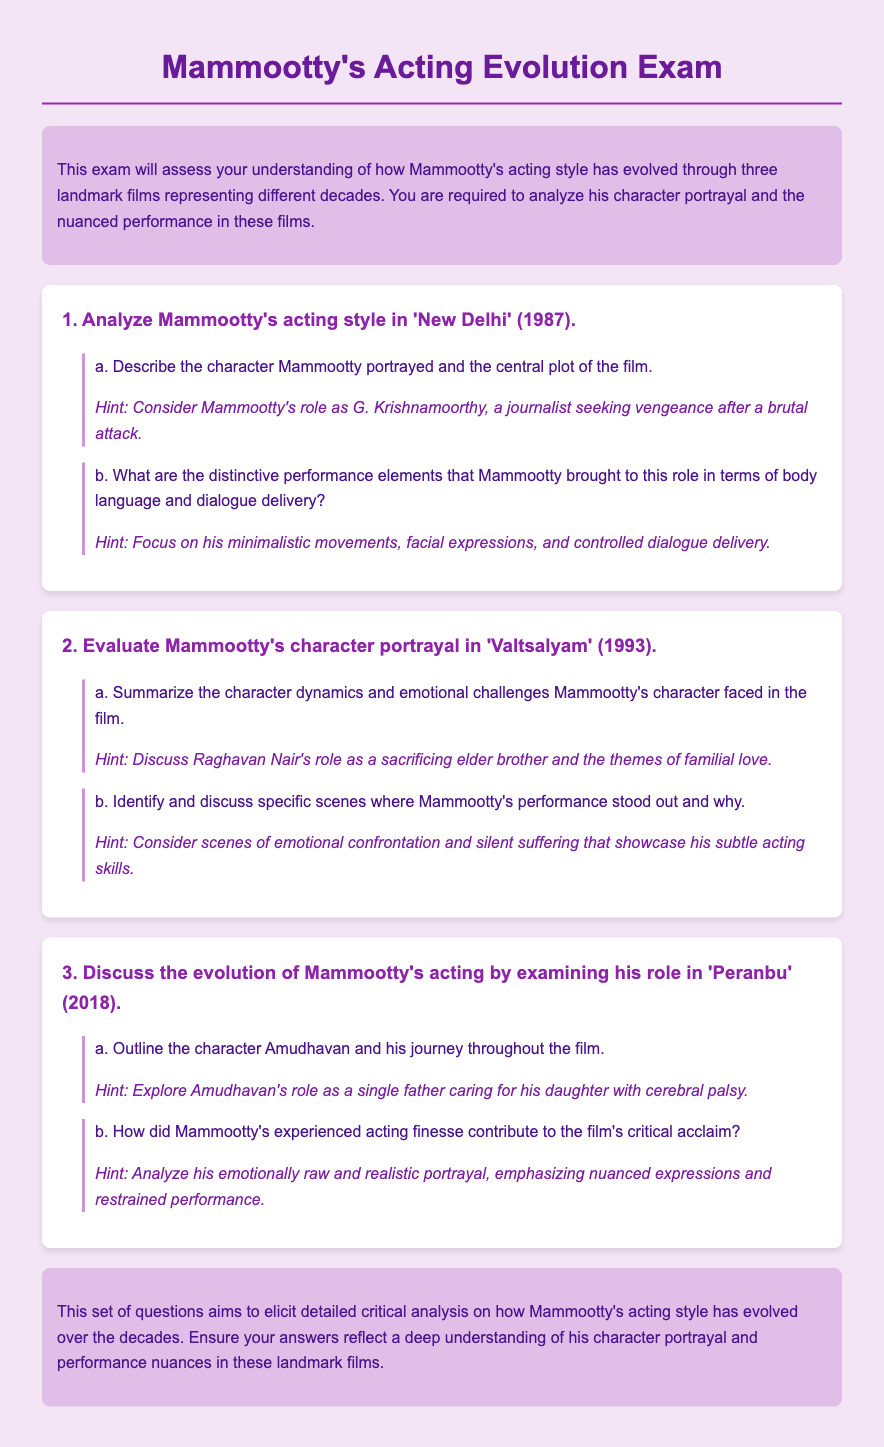What is the title of the exam? The title of the exam is mentioned in the header of the document.
Answer: Mammootty's Acting Evolution Exam In which year was the film 'New Delhi' released? The year of release is specified in the first question regarding Mammootty's acting style.
Answer: 1987 What character does Mammootty portray in 'Valtsalyam'? The character name is mentioned in the second question along with a summary.
Answer: Raghavan Nair Which film features Mammootty as a single father? The characterization specific to this role is highlighted in the third question about his role.
Answer: Peranbu What is the central theme in 'Valtsalyam'? The document discusses the emotional challenges faced by the character in terms of familial love.
Answer: Familial love Describe the performance style Mammootty used in 'New Delhi'. Performance elements are outlined in part (b) of the first question regarding this film.
Answer: Minimalistic movements What type of document is this exam? The document includes specific instructional content, which helps identify the type of document.
Answer: Exam What aspect of Mammootty's acting is emphasized in 'Peranbu'? This aspect is elaborated in part (b) of the third question analysing Mammootty's performance.
Answer: Emotionally raw portrayal Which decade does 'Valtsalyam' belong to? The decade is implicit based on the year of release provided in the question two.
Answer: 1990s 